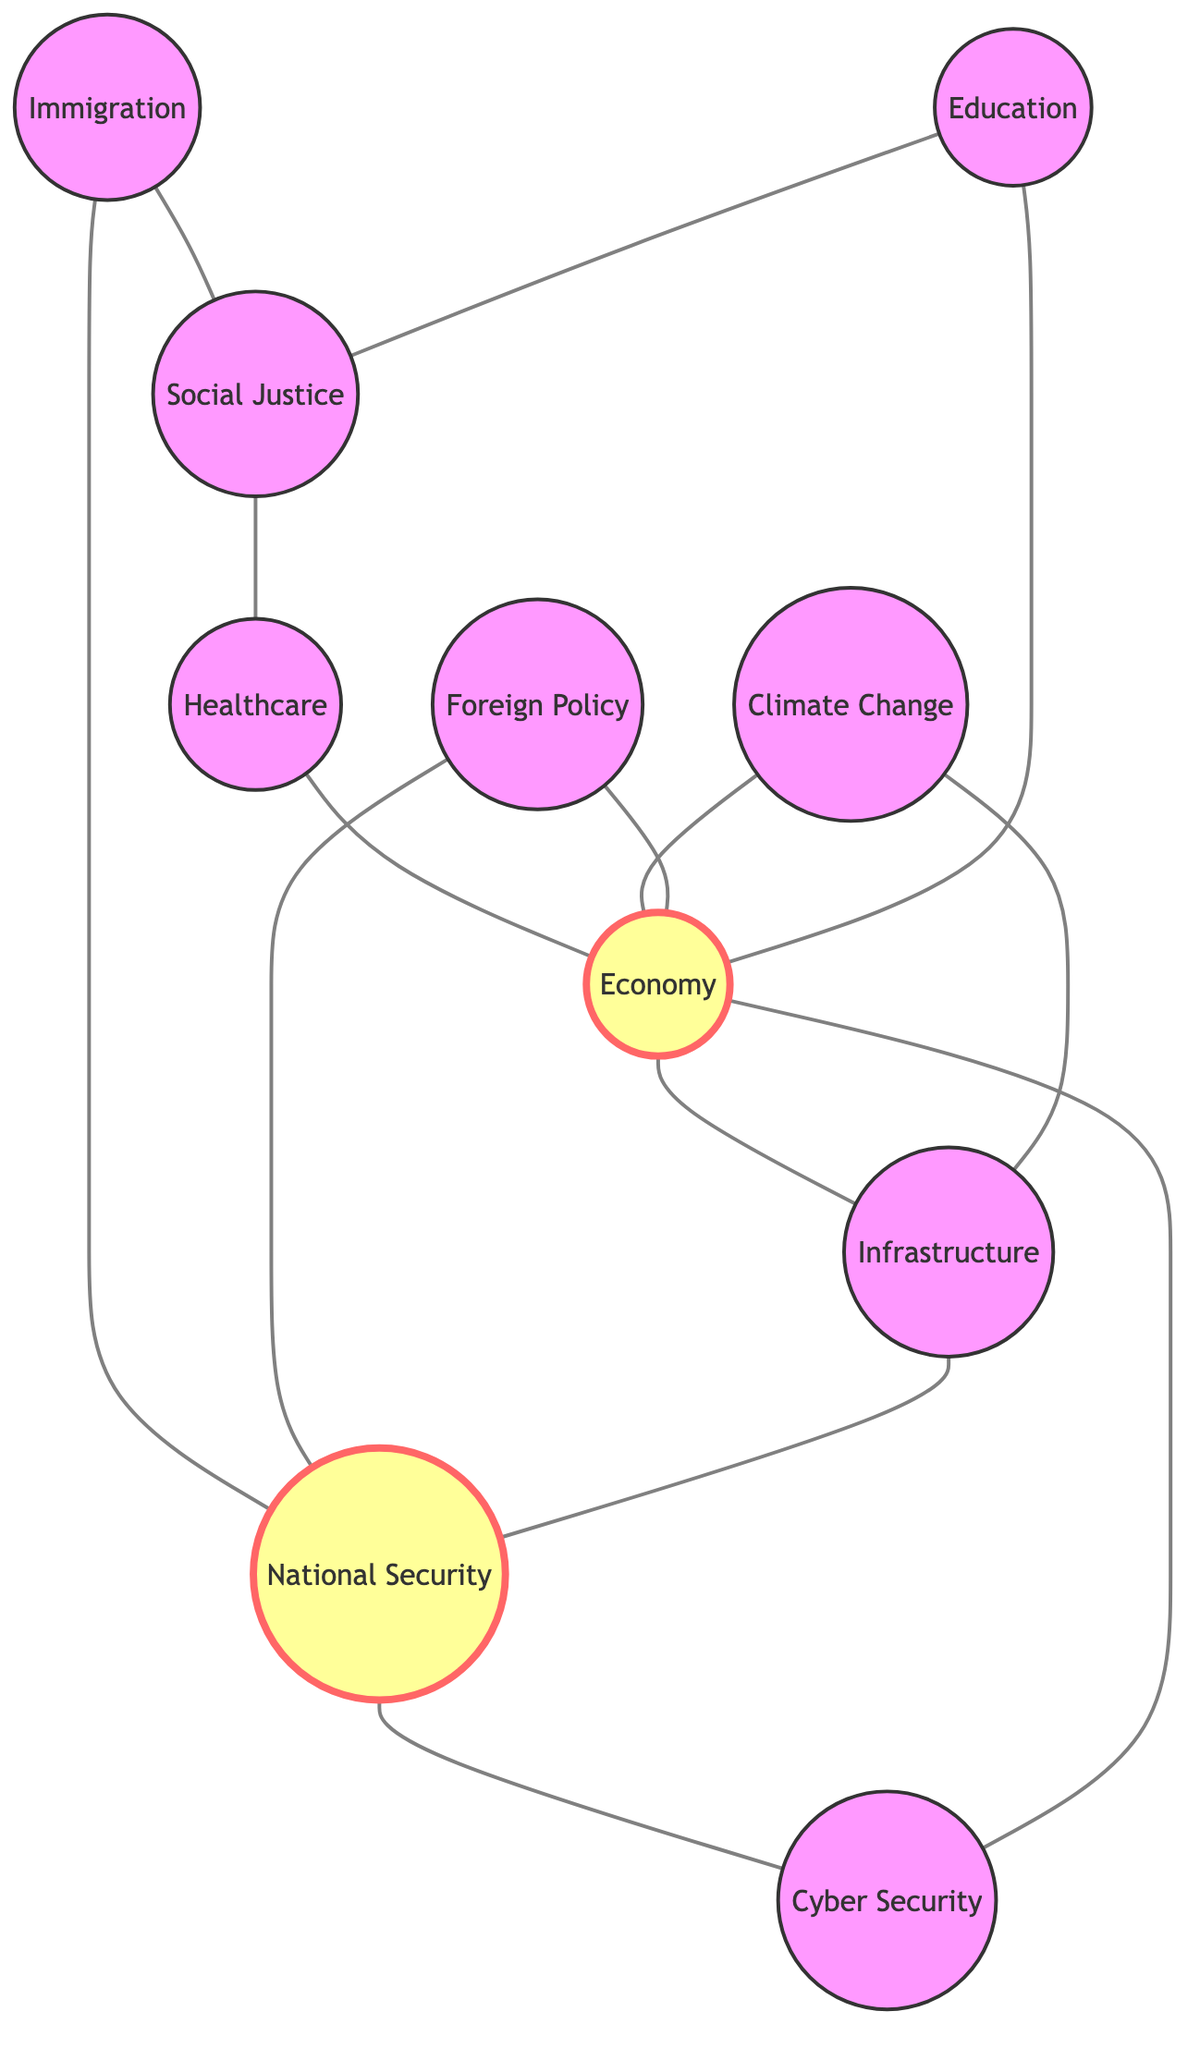What is the total number of nodes in the diagram? The diagram contains a list of nodes: Healthcare, Economy, Climate Change, Immigration, Foreign Policy, Education, Social Justice, Infrastructure, National Security, and Cyber Security. Counting these gives a total of 10 nodes.
Answer: 10 Which two nodes are directly connected to Education? By examining the edges connected to Education, they connect to Economy and Social Justice. The direct connections are reflected as edges in the graph.
Answer: Economy, Social Justice What is the relationship between Climate Change and Infrastructure? The diagram shows an edge connecting Climate Change and Infrastructure, indicating that they are directly related in the context of the discussion.
Answer: Directly connected How many edges are connected to the node representing Economy? To find the number of edges connected to Economy, we can count the edges: Economy is connected to Healthcare, Infrastructure, Climate Change, Foreign Policy, Education, and Cyber Security. That totals six edges.
Answer: 6 Which two topics are connected through the node of Immigration? Immigration is directly connected to Social Justice and National Security according to the edges in the diagram that link these nodes together.
Answer: Social Justice, National Security How are National Security and Cyber Security related in the diagram? National Security is directly connected to Cyber Security by an edge, signifying that they share a direct relationship in the themes discussed.
Answer: Directly connected What is the primary theme of the most connected node? By analyzing the connections, Economy connects to six other nodes, making it the most connected node in the graph, which implies it is a primary theme in this context.
Answer: Economy Are there any nodes that share a connection with both Immigration and National Security? Yes, National Security shares connections with Immigration through direct edges, and also has connections to Cyber Security, which relates indirectly. Immigration connects to National Security directly.
Answer: Yes 